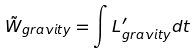Convert formula to latex. <formula><loc_0><loc_0><loc_500><loc_500>\tilde { W } _ { g r a v i t y } = \int L ^ { \prime } _ { g r a v i t y } d t</formula> 